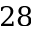Convert formula to latex. <formula><loc_0><loc_0><loc_500><loc_500>2 8</formula> 